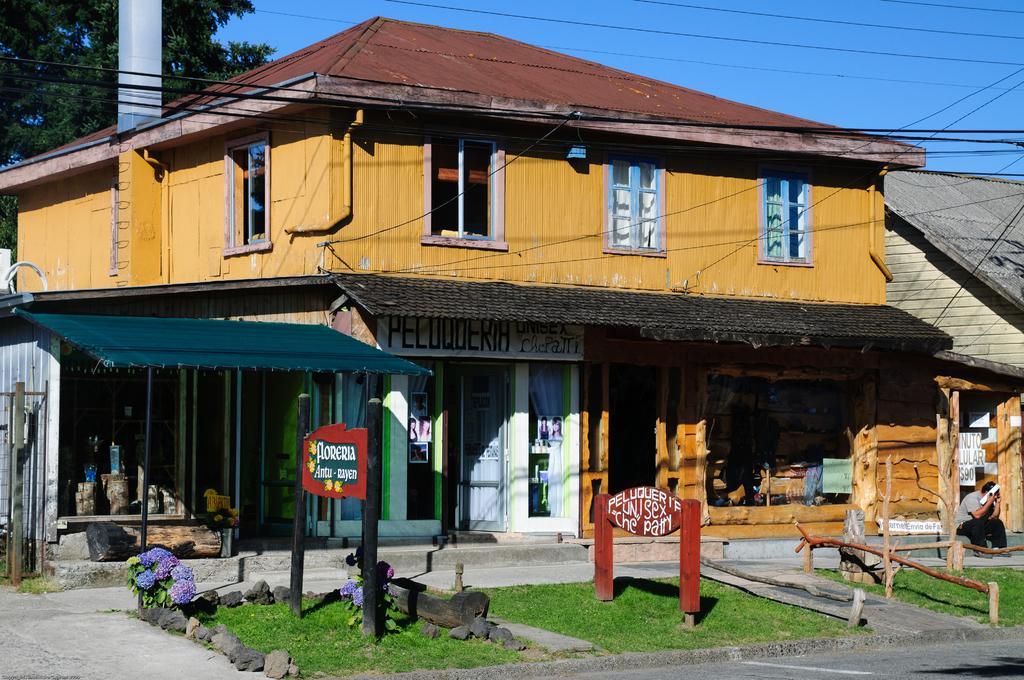Describe this image in one or two sentences. In this picture I can see buildings, boards which has something written on it and a person is sitting over here. I can also see wires, grass and some other objects on the ground. In the background I can see trees and the sky. Here I can see windows and doors. 